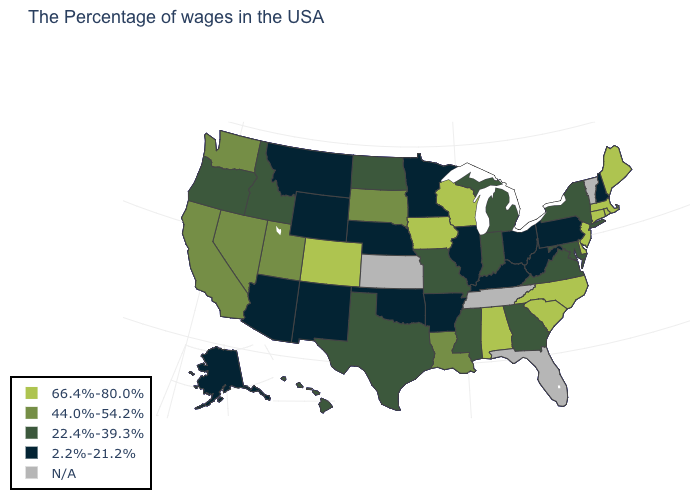What is the value of Colorado?
Quick response, please. 66.4%-80.0%. What is the highest value in states that border Nevada?
Be succinct. 44.0%-54.2%. What is the value of Massachusetts?
Keep it brief. 66.4%-80.0%. What is the value of North Dakota?
Answer briefly. 22.4%-39.3%. Does the first symbol in the legend represent the smallest category?
Write a very short answer. No. Which states have the lowest value in the USA?
Quick response, please. New Hampshire, Pennsylvania, West Virginia, Ohio, Kentucky, Illinois, Arkansas, Minnesota, Nebraska, Oklahoma, Wyoming, New Mexico, Montana, Arizona, Alaska. What is the value of Vermont?
Keep it brief. N/A. Among the states that border Wyoming , does Idaho have the lowest value?
Concise answer only. No. Name the states that have a value in the range 44.0%-54.2%?
Write a very short answer. Louisiana, South Dakota, Utah, Nevada, California, Washington. What is the value of South Dakota?
Concise answer only. 44.0%-54.2%. Name the states that have a value in the range 2.2%-21.2%?
Write a very short answer. New Hampshire, Pennsylvania, West Virginia, Ohio, Kentucky, Illinois, Arkansas, Minnesota, Nebraska, Oklahoma, Wyoming, New Mexico, Montana, Arizona, Alaska. Name the states that have a value in the range 44.0%-54.2%?
Give a very brief answer. Louisiana, South Dakota, Utah, Nevada, California, Washington. What is the value of New Mexico?
Answer briefly. 2.2%-21.2%. What is the highest value in the USA?
Short answer required. 66.4%-80.0%. 